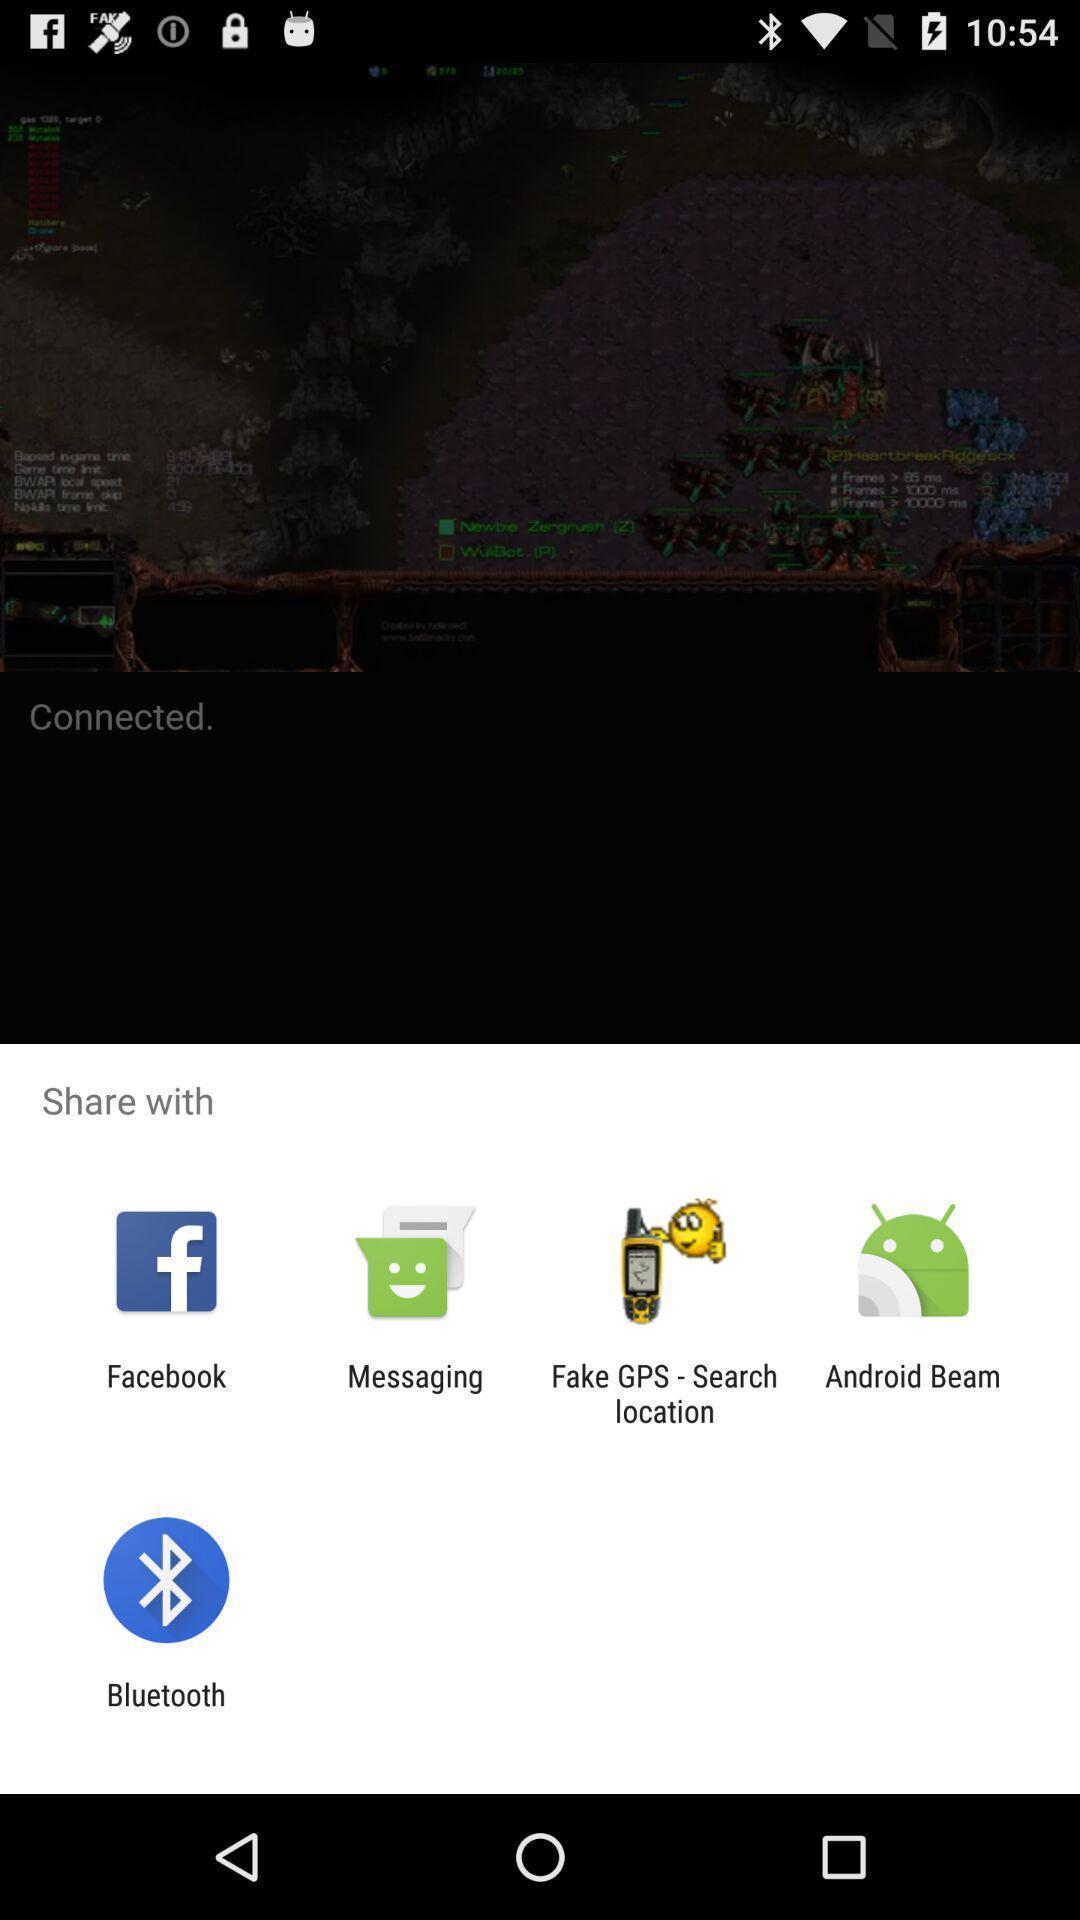Please provide a description for this image. Popup of different kinds of applications to share the info. 